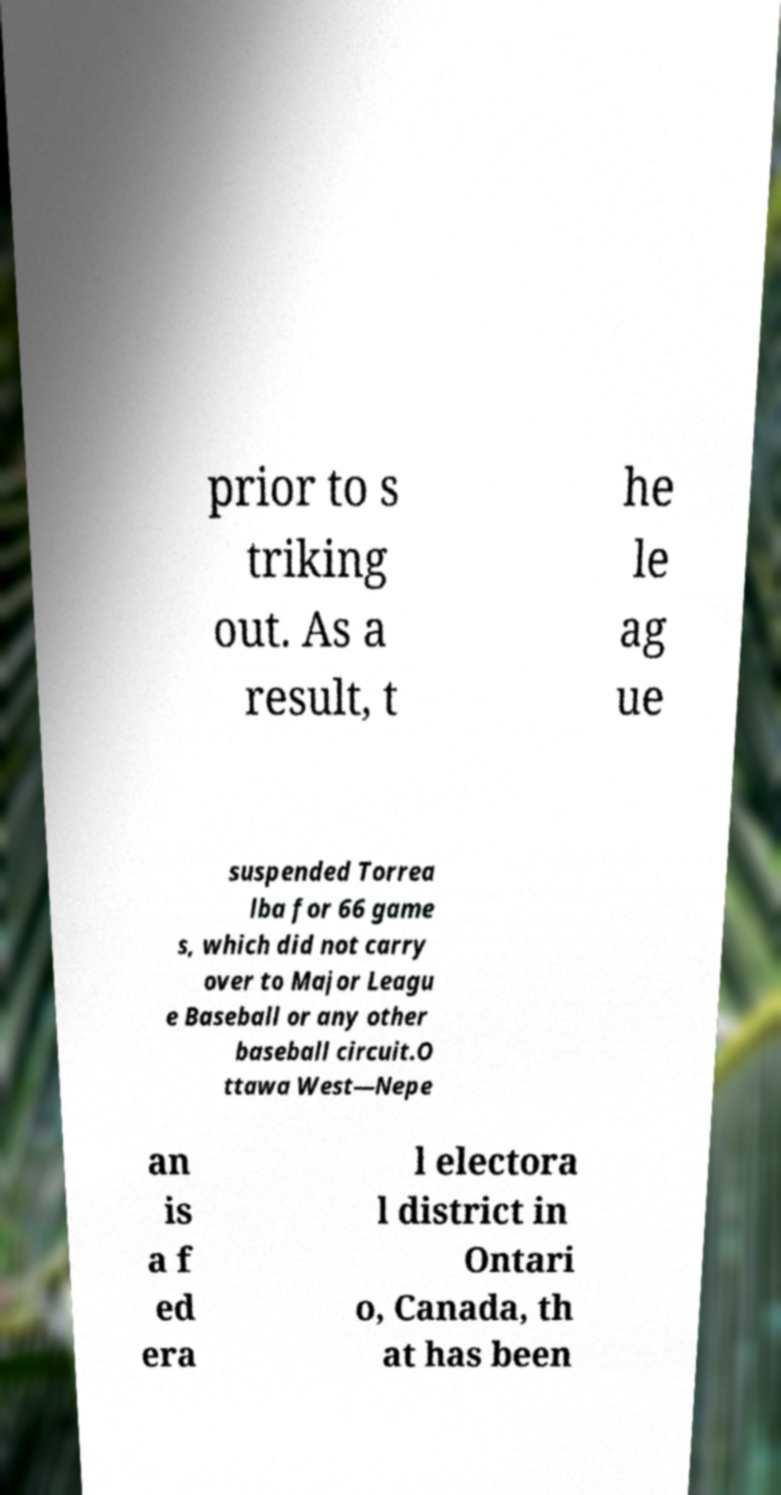Can you accurately transcribe the text from the provided image for me? prior to s triking out. As a result, t he le ag ue suspended Torrea lba for 66 game s, which did not carry over to Major Leagu e Baseball or any other baseball circuit.O ttawa West—Nepe an is a f ed era l electora l district in Ontari o, Canada, th at has been 